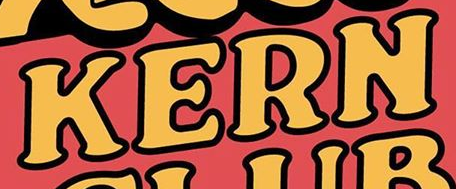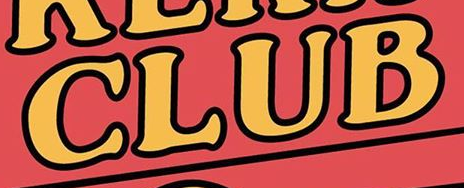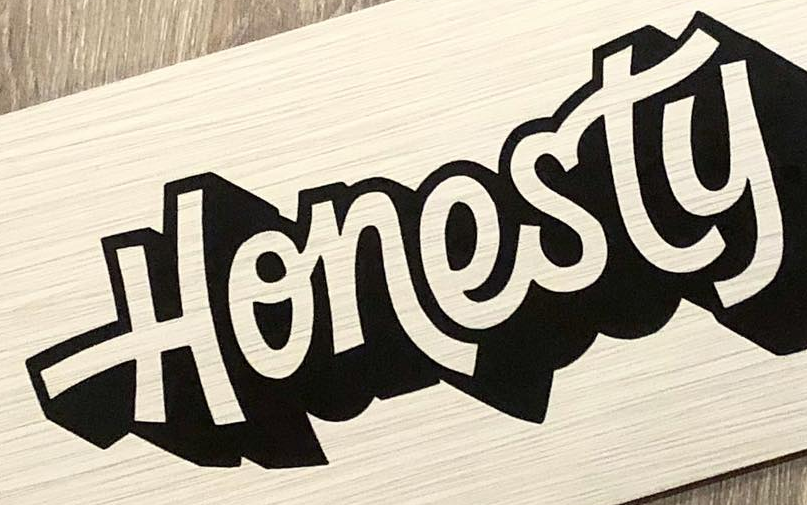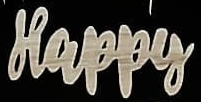What text is displayed in these images sequentially, separated by a semicolon? KERN; CLUB; Honesty; Happy 